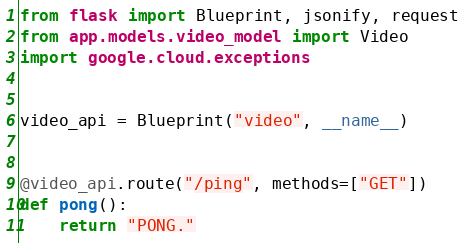Convert code to text. <code><loc_0><loc_0><loc_500><loc_500><_Python_>from flask import Blueprint, jsonify, request
from app.models.video_model import Video
import google.cloud.exceptions


video_api = Blueprint("video", __name__)


@video_api.route("/ping", methods=["GET"])
def pong():
    return "PONG."

</code> 